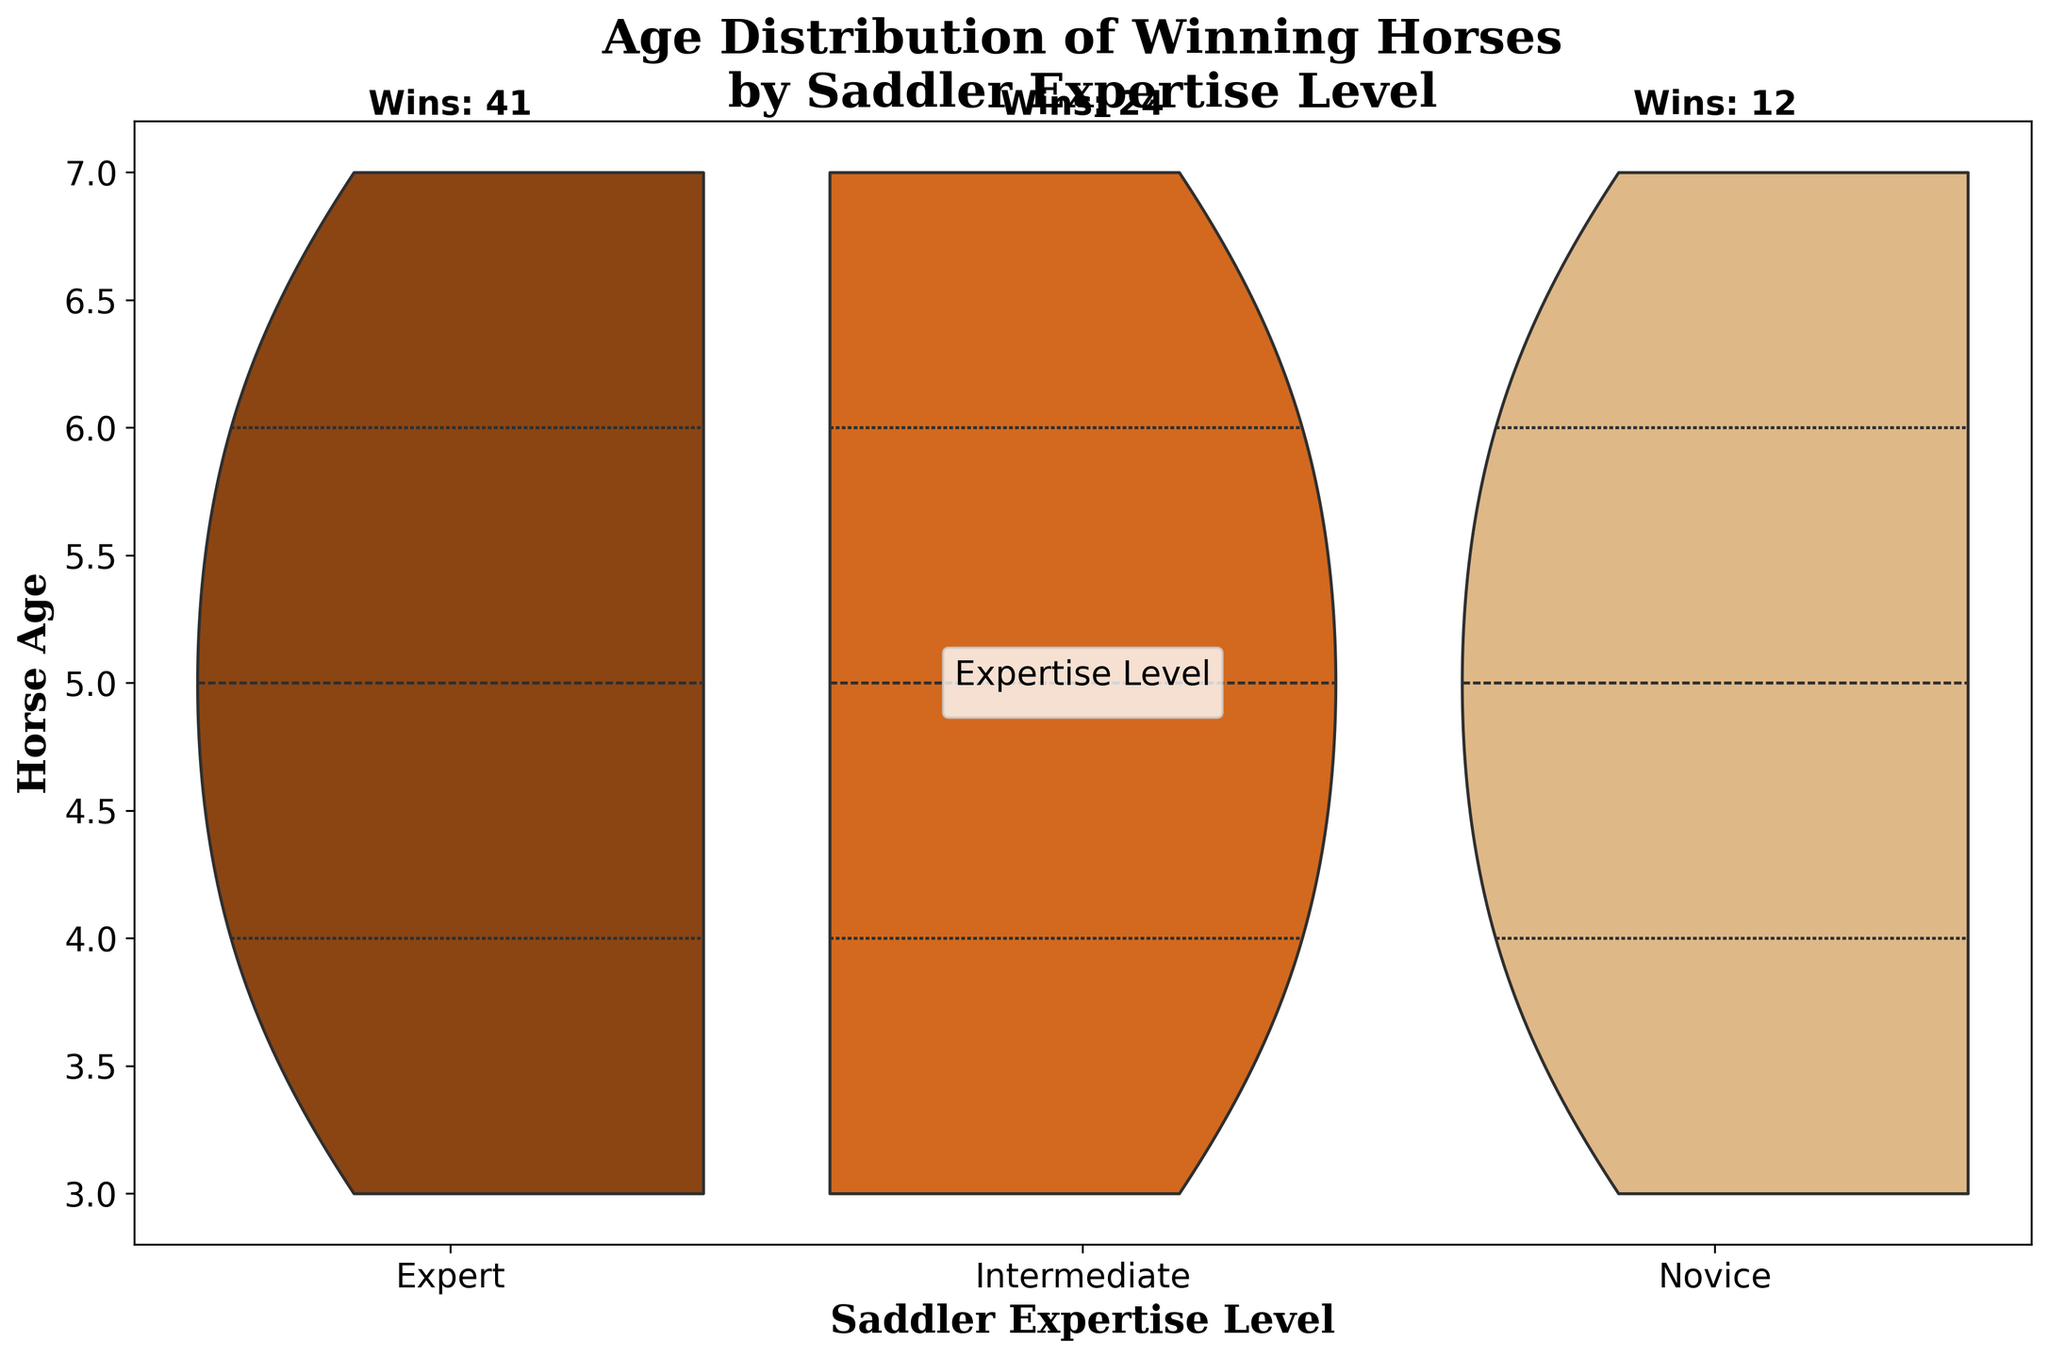What is the title of the figure? The title is displayed at the top of the figure. It reads "Age Distribution of Winning Horses by Saddler Expertise Level".
Answer: Age Distribution of Winning Horses by Saddler Expertise Level Which saddler expertise level has the highest total number of wins? The total number of wins is annotated near the top of each violin for each expertise level. The "Expert" category has the highest total with a wins annotation indicating 41 wins.
Answer: Expert What is the typical age range of winning horses for expert saddlers? The age range for each expertise level can be identified by the spread of the violin plot. For expert saddlers, the majority of the distribution covers ages between 4 and 6.
Answer: 4 to 6 How does the age distribution of winning horses compare between Expert and Novice saddlers? Comparing the violin plots for "Expert" and "Novice" shows that Expert saddlers have a broader and taller distribution between 4 and 6 years, indicating more wins in that age range, whereas novice saddlers have a more even but less dense distribution across the ages.
Answer: Broader and taller for Expert (4-6) vs. even but less dense for Novice Which expertise level sees winning horses predominantly at age 5? The violin plot with the highest peak at age 5 would indicate the level. For Expert saddlers, the plot peaks significantly at age 5.
Answer: Expert What is the median age of winning horses for intermediate saddlers? The median age is where the middle part of the distribution lies. For intermediate saddlers, the violin plot shows the median around age 5.
Answer: 5 How many more wins do expert saddlers have compared to novice saddlers? Adding the win counts noted on the figure for Expert (41) and Novice (12), the difference is calculated as 41 - 12.
Answer: 29 What does the split violin plot indicate about the age distribution between Intermediate and Expert saddlers? The split violin plot allows comparing the density and range of winning horse ages. For Intermediate, the distribution is spread across the ages but peaks at 4-5, while for Expert, it is more concentrated and denser between 4-6.
Answer: Spread across but peaks at 4-5 for Intermediate, concentrated and denser at 4-6 for Expert Which age group of winning horses has the least representation across all expertise levels? By observing the distribution tails of all levels, horses aged 7 show the smallest density in all violin sections, indicating the least representation.
Answer: 7 years What is the sum of the wins for horses aged 6 across all saddler levels? Summing the individual wins annotated in the data for each level at age 6: 11 (Expert) + 5 (Intermediate) + 3 (Novice) gives a total.
Answer: 19 